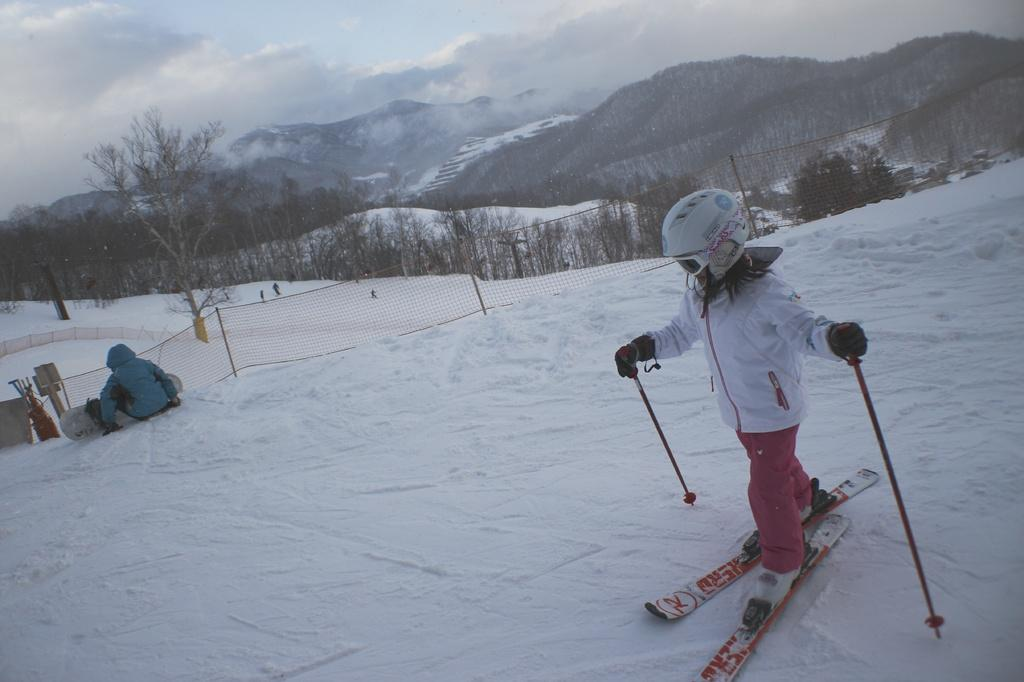Who can be seen in the image? There are people in the image. What activity is the boy engaged in? The boy is skiing in the ice. What object is present in the image that might be used for sports or games? There is a net in the image. What type of natural environment is visible in the image? There are trees in the image. What type of fork can be seen in the boy's mouth while skiing in the image? There is no fork present in the image, and the boy's mouth is not visible while skiing. 